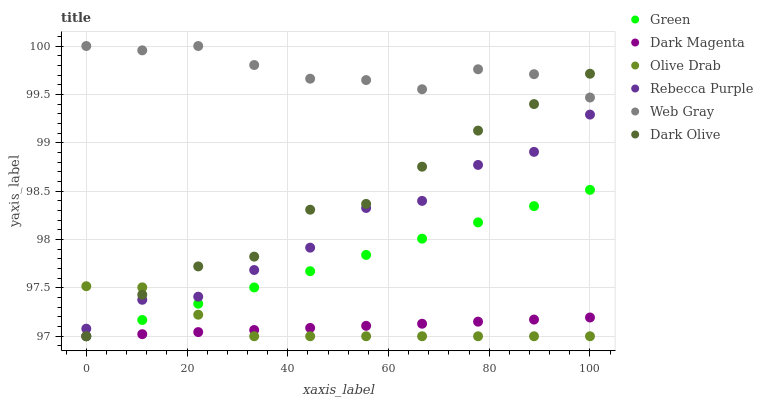Does Dark Magenta have the minimum area under the curve?
Answer yes or no. Yes. Does Web Gray have the maximum area under the curve?
Answer yes or no. Yes. Does Dark Olive have the minimum area under the curve?
Answer yes or no. No. Does Dark Olive have the maximum area under the curve?
Answer yes or no. No. Is Green the smoothest?
Answer yes or no. Yes. Is Rebecca Purple the roughest?
Answer yes or no. Yes. Is Dark Magenta the smoothest?
Answer yes or no. No. Is Dark Magenta the roughest?
Answer yes or no. No. Does Dark Magenta have the lowest value?
Answer yes or no. Yes. Does Rebecca Purple have the lowest value?
Answer yes or no. No. Does Web Gray have the highest value?
Answer yes or no. Yes. Does Dark Olive have the highest value?
Answer yes or no. No. Is Dark Magenta less than Rebecca Purple?
Answer yes or no. Yes. Is Web Gray greater than Dark Magenta?
Answer yes or no. Yes. Does Olive Drab intersect Dark Olive?
Answer yes or no. Yes. Is Olive Drab less than Dark Olive?
Answer yes or no. No. Is Olive Drab greater than Dark Olive?
Answer yes or no. No. Does Dark Magenta intersect Rebecca Purple?
Answer yes or no. No. 